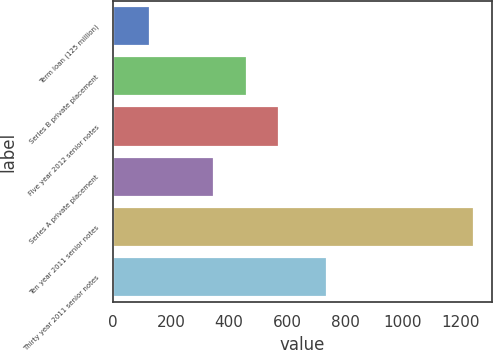Convert chart to OTSL. <chart><loc_0><loc_0><loc_500><loc_500><bar_chart><fcel>Term loan (125 million)<fcel>Series B private placement<fcel>Five year 2012 senior notes<fcel>Series A private placement<fcel>Ten year 2011 senior notes<fcel>Thirty year 2011 senior notes<nl><fcel>125<fcel>460.61<fcel>572.48<fcel>348.74<fcel>1243.7<fcel>738.3<nl></chart> 